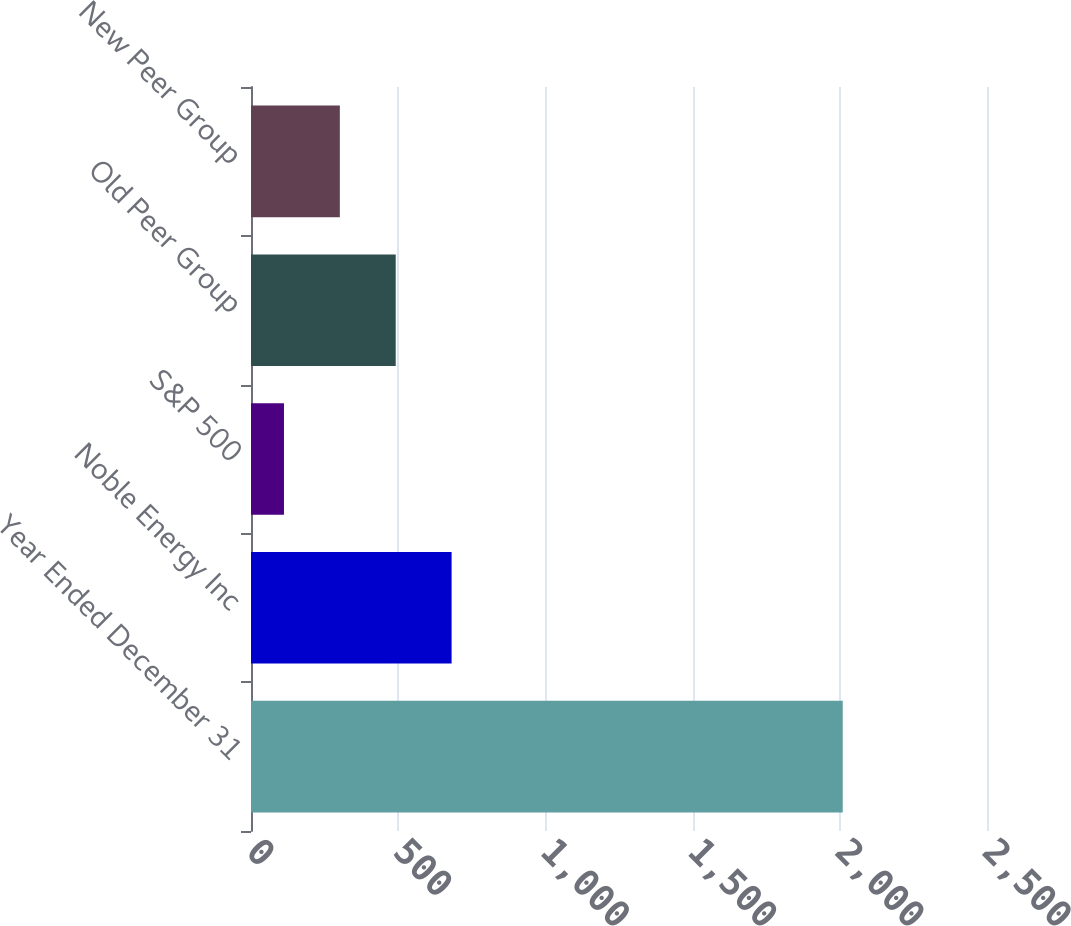Convert chart. <chart><loc_0><loc_0><loc_500><loc_500><bar_chart><fcel>Year Ended December 31<fcel>Noble Energy Inc<fcel>S&P 500<fcel>Old Peer Group<fcel>New Peer Group<nl><fcel>2010<fcel>681.39<fcel>111.99<fcel>491.59<fcel>301.79<nl></chart> 